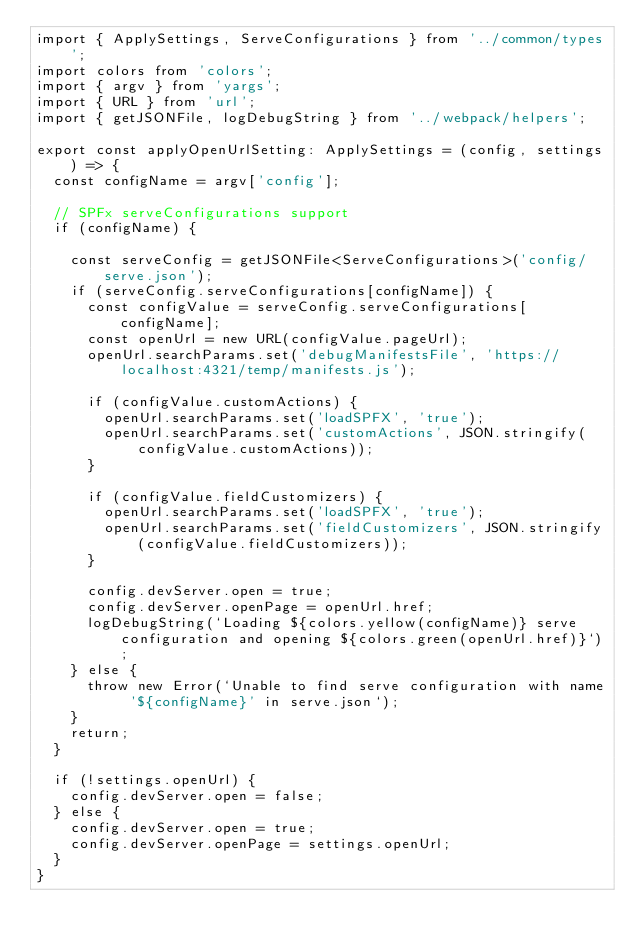Convert code to text. <code><loc_0><loc_0><loc_500><loc_500><_TypeScript_>import { ApplySettings, ServeConfigurations } from '../common/types';
import colors from 'colors';
import { argv } from 'yargs';
import { URL } from 'url';
import { getJSONFile, logDebugString } from '../webpack/helpers';

export const applyOpenUrlSetting: ApplySettings = (config, settings) => {
  const configName = argv['config'];

  // SPFx serveConfigurations support
  if (configName) {

    const serveConfig = getJSONFile<ServeConfigurations>('config/serve.json');
    if (serveConfig.serveConfigurations[configName]) {
      const configValue = serveConfig.serveConfigurations[configName];
      const openUrl = new URL(configValue.pageUrl);
      openUrl.searchParams.set('debugManifestsFile', 'https://localhost:4321/temp/manifests.js');

      if (configValue.customActions) {
        openUrl.searchParams.set('loadSPFX', 'true');
        openUrl.searchParams.set('customActions', JSON.stringify(configValue.customActions));
      }

      if (configValue.fieldCustomizers) {
        openUrl.searchParams.set('loadSPFX', 'true');
        openUrl.searchParams.set('fieldCustomizers', JSON.stringify(configValue.fieldCustomizers));
      }

      config.devServer.open = true;
      config.devServer.openPage = openUrl.href;
      logDebugString(`Loading ${colors.yellow(configName)} serve configuration and opening ${colors.green(openUrl.href)}`);
    } else {
      throw new Error(`Unable to find serve configuration with name '${configName}' in serve.json`);
    }
    return;
  }

  if (!settings.openUrl) {
    config.devServer.open = false;
  } else {
    config.devServer.open = true;
    config.devServer.openPage = settings.openUrl;
  }
}
</code> 